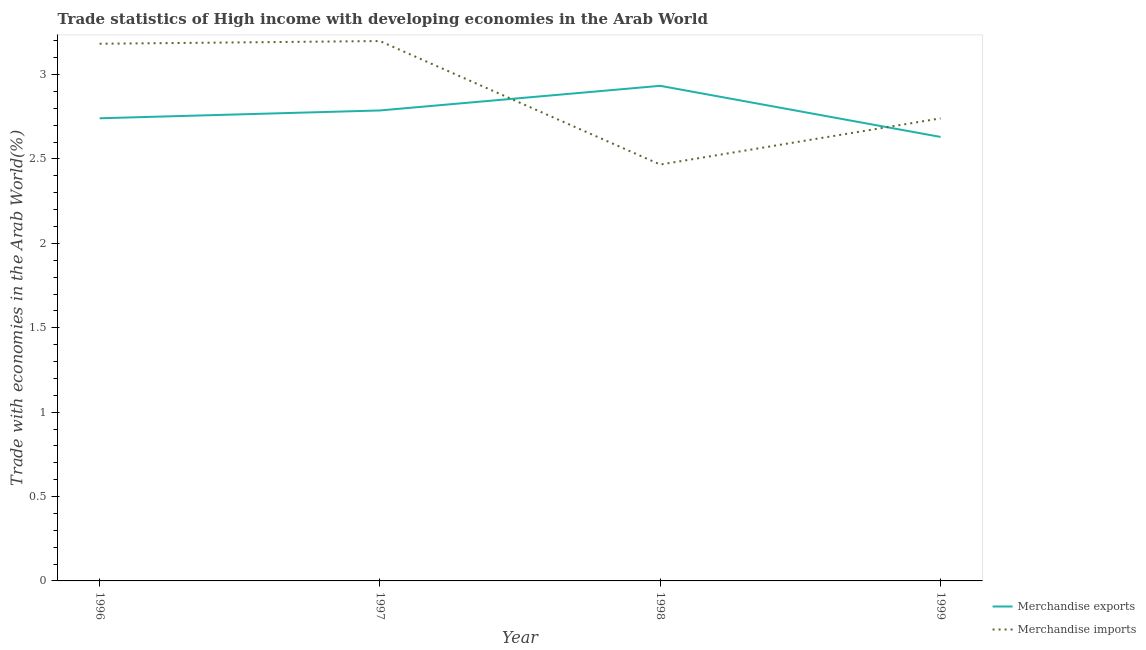How many different coloured lines are there?
Ensure brevity in your answer.  2. Does the line corresponding to merchandise exports intersect with the line corresponding to merchandise imports?
Your answer should be very brief. Yes. What is the merchandise exports in 1998?
Your response must be concise. 2.93. Across all years, what is the maximum merchandise imports?
Make the answer very short. 3.2. Across all years, what is the minimum merchandise imports?
Give a very brief answer. 2.47. What is the total merchandise imports in the graph?
Your response must be concise. 11.59. What is the difference between the merchandise exports in 1996 and that in 1997?
Offer a terse response. -0.05. What is the difference between the merchandise exports in 1999 and the merchandise imports in 1996?
Your answer should be very brief. -0.55. What is the average merchandise exports per year?
Offer a very short reply. 2.77. In the year 1998, what is the difference between the merchandise imports and merchandise exports?
Keep it short and to the point. -0.47. What is the ratio of the merchandise imports in 1997 to that in 1998?
Offer a terse response. 1.3. Is the merchandise imports in 1997 less than that in 1998?
Make the answer very short. No. Is the difference between the merchandise imports in 1997 and 1999 greater than the difference between the merchandise exports in 1997 and 1999?
Provide a short and direct response. Yes. What is the difference between the highest and the second highest merchandise imports?
Offer a terse response. 0.02. What is the difference between the highest and the lowest merchandise imports?
Provide a succinct answer. 0.73. In how many years, is the merchandise exports greater than the average merchandise exports taken over all years?
Your answer should be compact. 2. Does the merchandise exports monotonically increase over the years?
Your response must be concise. No. What is the difference between two consecutive major ticks on the Y-axis?
Make the answer very short. 0.5. Are the values on the major ticks of Y-axis written in scientific E-notation?
Your response must be concise. No. Does the graph contain any zero values?
Your answer should be compact. No. Does the graph contain grids?
Offer a terse response. No. Where does the legend appear in the graph?
Offer a terse response. Bottom right. How are the legend labels stacked?
Give a very brief answer. Vertical. What is the title of the graph?
Keep it short and to the point. Trade statistics of High income with developing economies in the Arab World. Does "Register a property" appear as one of the legend labels in the graph?
Keep it short and to the point. No. What is the label or title of the Y-axis?
Offer a terse response. Trade with economies in the Arab World(%). What is the Trade with economies in the Arab World(%) in Merchandise exports in 1996?
Offer a very short reply. 2.74. What is the Trade with economies in the Arab World(%) of Merchandise imports in 1996?
Provide a short and direct response. 3.18. What is the Trade with economies in the Arab World(%) in Merchandise exports in 1997?
Offer a very short reply. 2.79. What is the Trade with economies in the Arab World(%) in Merchandise imports in 1997?
Offer a very short reply. 3.2. What is the Trade with economies in the Arab World(%) of Merchandise exports in 1998?
Provide a succinct answer. 2.93. What is the Trade with economies in the Arab World(%) of Merchandise imports in 1998?
Provide a succinct answer. 2.47. What is the Trade with economies in the Arab World(%) of Merchandise exports in 1999?
Your answer should be compact. 2.63. What is the Trade with economies in the Arab World(%) in Merchandise imports in 1999?
Offer a terse response. 2.74. Across all years, what is the maximum Trade with economies in the Arab World(%) in Merchandise exports?
Your response must be concise. 2.93. Across all years, what is the maximum Trade with economies in the Arab World(%) of Merchandise imports?
Your response must be concise. 3.2. Across all years, what is the minimum Trade with economies in the Arab World(%) in Merchandise exports?
Offer a terse response. 2.63. Across all years, what is the minimum Trade with economies in the Arab World(%) in Merchandise imports?
Make the answer very short. 2.47. What is the total Trade with economies in the Arab World(%) of Merchandise exports in the graph?
Ensure brevity in your answer.  11.09. What is the total Trade with economies in the Arab World(%) of Merchandise imports in the graph?
Ensure brevity in your answer.  11.59. What is the difference between the Trade with economies in the Arab World(%) in Merchandise exports in 1996 and that in 1997?
Make the answer very short. -0.05. What is the difference between the Trade with economies in the Arab World(%) in Merchandise imports in 1996 and that in 1997?
Provide a succinct answer. -0.02. What is the difference between the Trade with economies in the Arab World(%) of Merchandise exports in 1996 and that in 1998?
Provide a short and direct response. -0.19. What is the difference between the Trade with economies in the Arab World(%) of Merchandise imports in 1996 and that in 1998?
Your answer should be very brief. 0.72. What is the difference between the Trade with economies in the Arab World(%) of Merchandise exports in 1996 and that in 1999?
Make the answer very short. 0.11. What is the difference between the Trade with economies in the Arab World(%) in Merchandise imports in 1996 and that in 1999?
Offer a terse response. 0.44. What is the difference between the Trade with economies in the Arab World(%) in Merchandise exports in 1997 and that in 1998?
Provide a succinct answer. -0.15. What is the difference between the Trade with economies in the Arab World(%) of Merchandise imports in 1997 and that in 1998?
Give a very brief answer. 0.73. What is the difference between the Trade with economies in the Arab World(%) of Merchandise exports in 1997 and that in 1999?
Give a very brief answer. 0.16. What is the difference between the Trade with economies in the Arab World(%) in Merchandise imports in 1997 and that in 1999?
Provide a succinct answer. 0.46. What is the difference between the Trade with economies in the Arab World(%) of Merchandise exports in 1998 and that in 1999?
Make the answer very short. 0.3. What is the difference between the Trade with economies in the Arab World(%) of Merchandise imports in 1998 and that in 1999?
Your answer should be very brief. -0.27. What is the difference between the Trade with economies in the Arab World(%) in Merchandise exports in 1996 and the Trade with economies in the Arab World(%) in Merchandise imports in 1997?
Your answer should be very brief. -0.46. What is the difference between the Trade with economies in the Arab World(%) of Merchandise exports in 1996 and the Trade with economies in the Arab World(%) of Merchandise imports in 1998?
Your response must be concise. 0.27. What is the difference between the Trade with economies in the Arab World(%) of Merchandise exports in 1996 and the Trade with economies in the Arab World(%) of Merchandise imports in 1999?
Offer a terse response. 0. What is the difference between the Trade with economies in the Arab World(%) in Merchandise exports in 1997 and the Trade with economies in the Arab World(%) in Merchandise imports in 1998?
Offer a terse response. 0.32. What is the difference between the Trade with economies in the Arab World(%) in Merchandise exports in 1997 and the Trade with economies in the Arab World(%) in Merchandise imports in 1999?
Offer a terse response. 0.05. What is the difference between the Trade with economies in the Arab World(%) of Merchandise exports in 1998 and the Trade with economies in the Arab World(%) of Merchandise imports in 1999?
Your answer should be very brief. 0.19. What is the average Trade with economies in the Arab World(%) of Merchandise exports per year?
Your answer should be compact. 2.77. What is the average Trade with economies in the Arab World(%) in Merchandise imports per year?
Your answer should be very brief. 2.9. In the year 1996, what is the difference between the Trade with economies in the Arab World(%) of Merchandise exports and Trade with economies in the Arab World(%) of Merchandise imports?
Give a very brief answer. -0.44. In the year 1997, what is the difference between the Trade with economies in the Arab World(%) in Merchandise exports and Trade with economies in the Arab World(%) in Merchandise imports?
Your answer should be compact. -0.41. In the year 1998, what is the difference between the Trade with economies in the Arab World(%) in Merchandise exports and Trade with economies in the Arab World(%) in Merchandise imports?
Your response must be concise. 0.47. In the year 1999, what is the difference between the Trade with economies in the Arab World(%) in Merchandise exports and Trade with economies in the Arab World(%) in Merchandise imports?
Your answer should be compact. -0.11. What is the ratio of the Trade with economies in the Arab World(%) in Merchandise exports in 1996 to that in 1997?
Keep it short and to the point. 0.98. What is the ratio of the Trade with economies in the Arab World(%) in Merchandise imports in 1996 to that in 1997?
Your answer should be compact. 0.99. What is the ratio of the Trade with economies in the Arab World(%) of Merchandise exports in 1996 to that in 1998?
Make the answer very short. 0.93. What is the ratio of the Trade with economies in the Arab World(%) in Merchandise imports in 1996 to that in 1998?
Give a very brief answer. 1.29. What is the ratio of the Trade with economies in the Arab World(%) in Merchandise exports in 1996 to that in 1999?
Your response must be concise. 1.04. What is the ratio of the Trade with economies in the Arab World(%) of Merchandise imports in 1996 to that in 1999?
Provide a succinct answer. 1.16. What is the ratio of the Trade with economies in the Arab World(%) of Merchandise exports in 1997 to that in 1998?
Keep it short and to the point. 0.95. What is the ratio of the Trade with economies in the Arab World(%) of Merchandise imports in 1997 to that in 1998?
Your answer should be very brief. 1.3. What is the ratio of the Trade with economies in the Arab World(%) in Merchandise exports in 1997 to that in 1999?
Your answer should be compact. 1.06. What is the ratio of the Trade with economies in the Arab World(%) of Merchandise imports in 1997 to that in 1999?
Your answer should be very brief. 1.17. What is the ratio of the Trade with economies in the Arab World(%) of Merchandise exports in 1998 to that in 1999?
Your answer should be very brief. 1.12. What is the ratio of the Trade with economies in the Arab World(%) of Merchandise imports in 1998 to that in 1999?
Provide a succinct answer. 0.9. What is the difference between the highest and the second highest Trade with economies in the Arab World(%) of Merchandise exports?
Provide a short and direct response. 0.15. What is the difference between the highest and the second highest Trade with economies in the Arab World(%) in Merchandise imports?
Provide a succinct answer. 0.02. What is the difference between the highest and the lowest Trade with economies in the Arab World(%) of Merchandise exports?
Offer a very short reply. 0.3. What is the difference between the highest and the lowest Trade with economies in the Arab World(%) of Merchandise imports?
Make the answer very short. 0.73. 